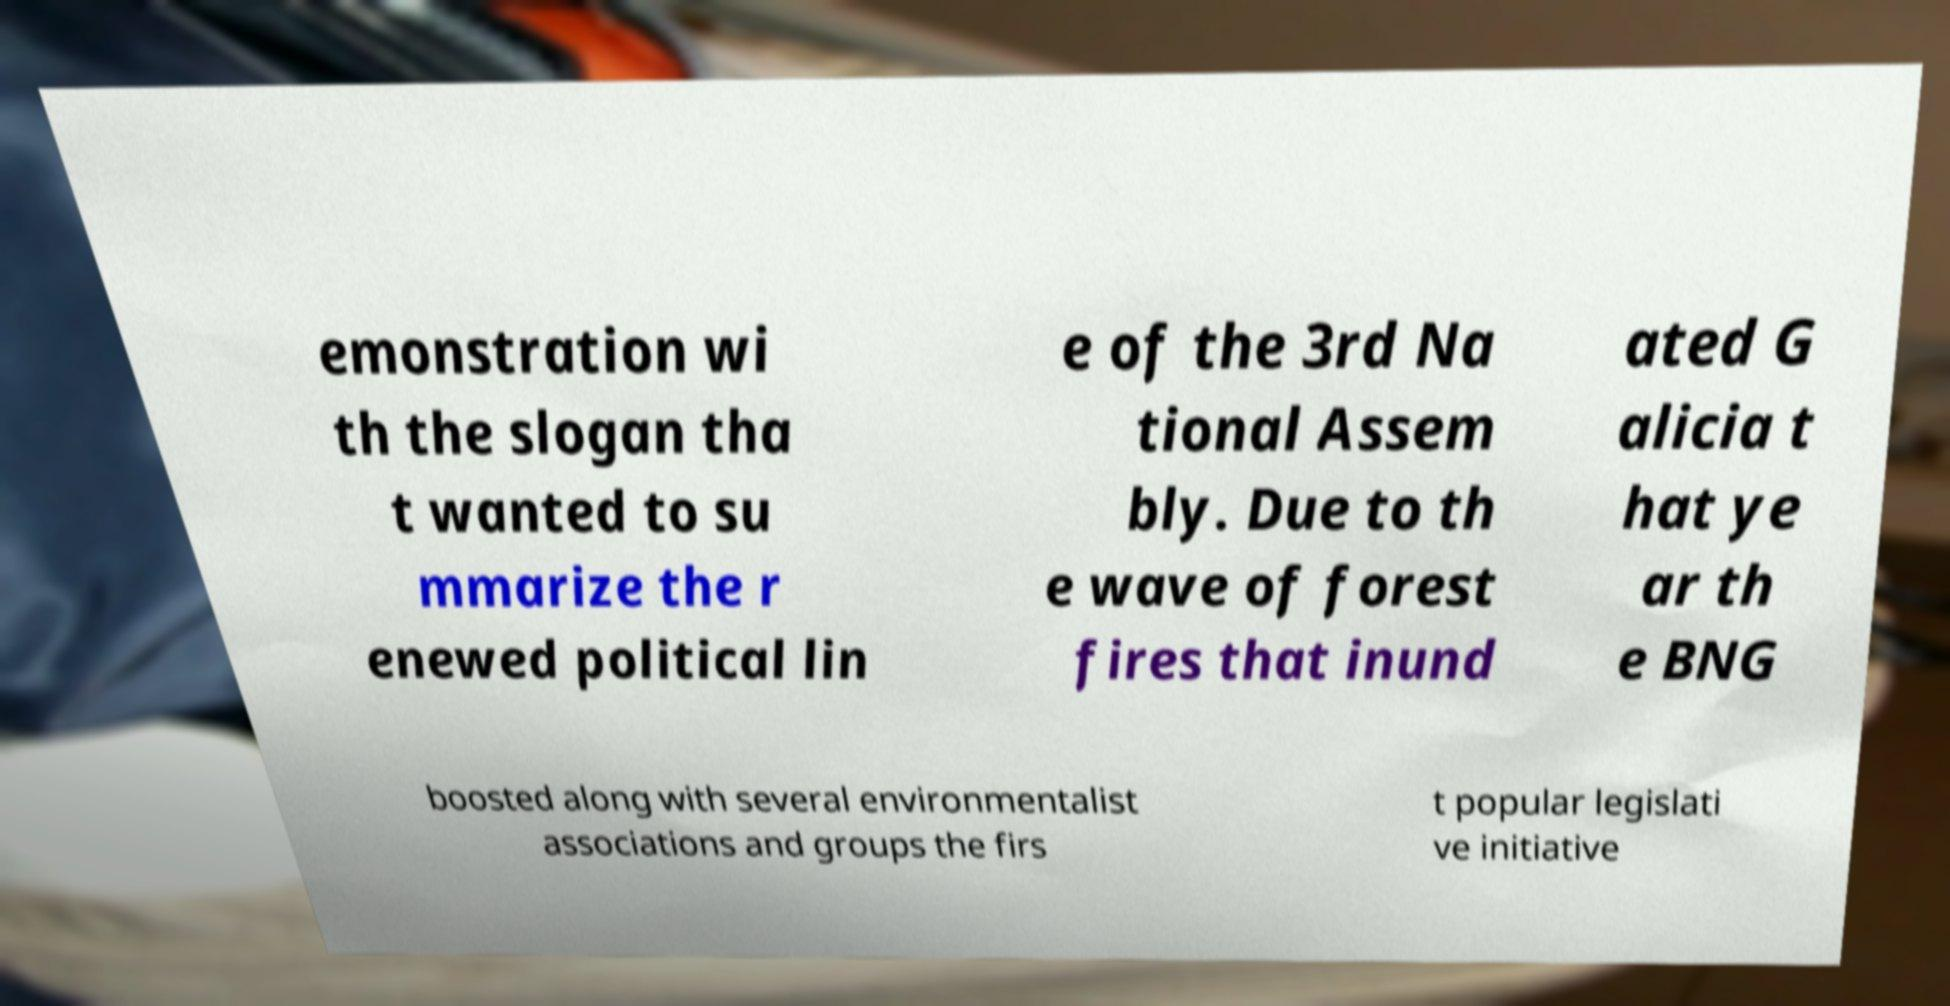There's text embedded in this image that I need extracted. Can you transcribe it verbatim? emonstration wi th the slogan tha t wanted to su mmarize the r enewed political lin e of the 3rd Na tional Assem bly. Due to th e wave of forest fires that inund ated G alicia t hat ye ar th e BNG boosted along with several environmentalist associations and groups the firs t popular legislati ve initiative 